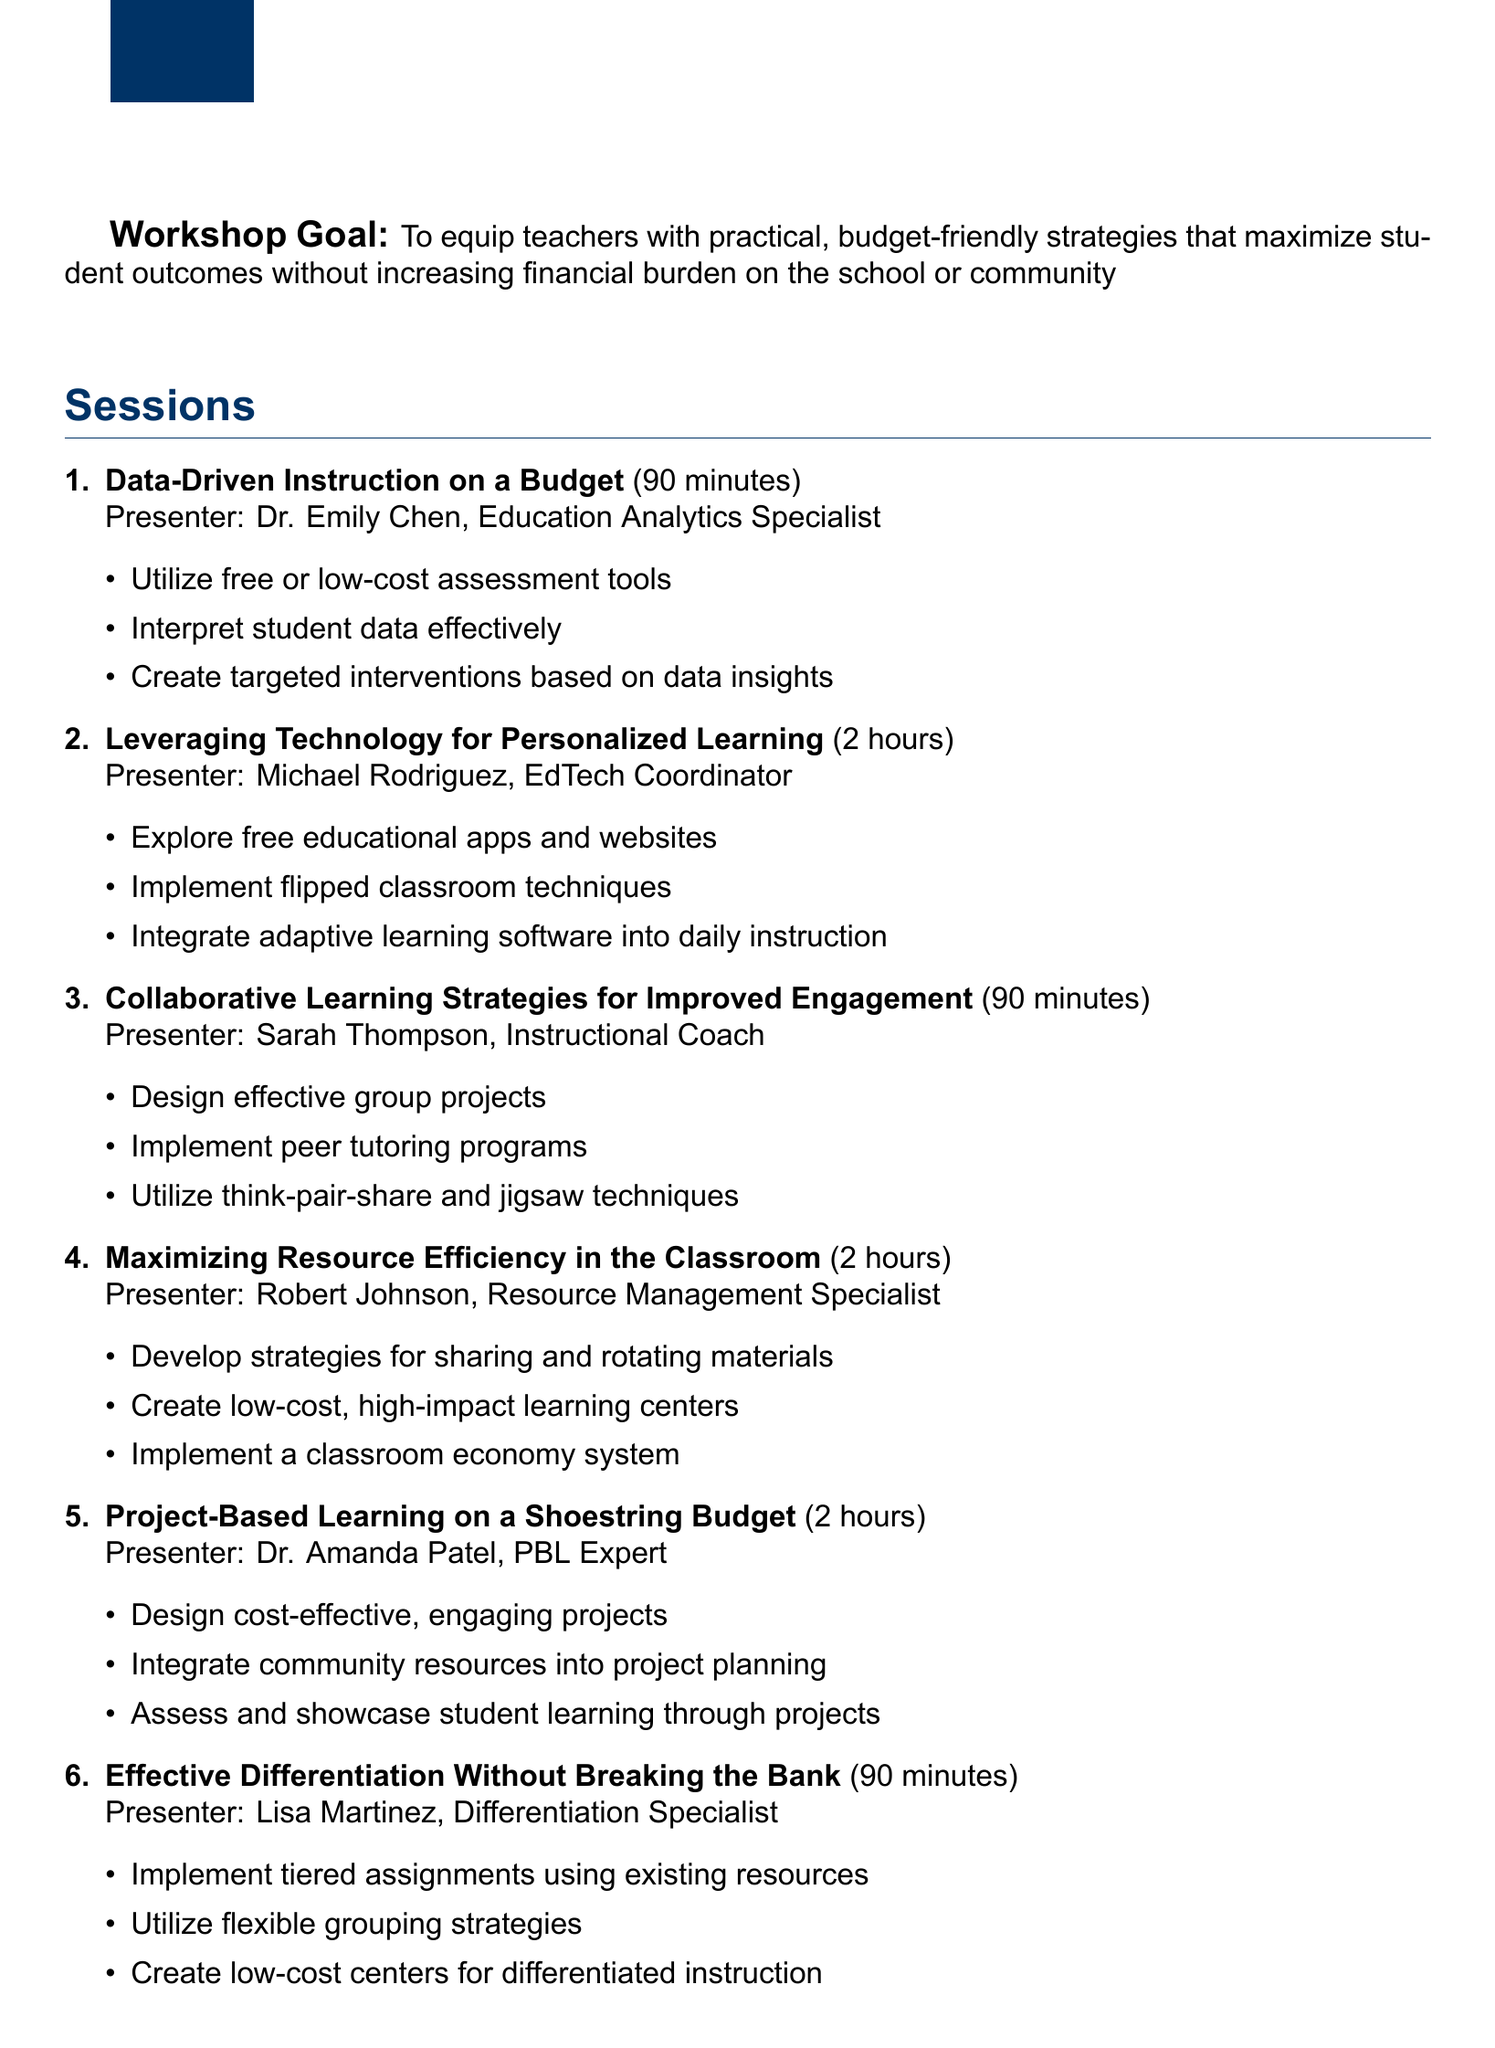What is the title of the workshop? The title of the workshop is stated clearly at the top of the document.
Answer: Cost-Effective, High-Impact Teaching Methods: Professional Development Series Who is the presenter for the session on Data-Driven Instruction? The session details include the name of the presenter at the end of each session's objectives.
Answer: Dr. Emily Chen How long is the session on Project-Based Learning? The duration is provided for each session in the document after the title.
Answer: 2 hours What is one objective of the Maximizing Resource Efficiency session? The document lists specific objectives under each session.
Answer: Create low-cost, high-impact learning centers How many sessions are included in the workshop? The document enumerates the sessions to clarify the total number.
Answer: 6 What additional resource focuses on sharing budget-friendly strategies? The document lists various additional resources with brief descriptions, which includes an idea exchange forum.
Answer: Cost-Saving Idea Exchange Forum What type of support follows the workshops? The final part of the document outlines the support available after the workshops.
Answer: Monthly peer learning circles What evaluation method involves student performance data? The document specifies several evaluation methods used for assessing the workshops, including one related to student performance.
Answer: Student performance data analysis 